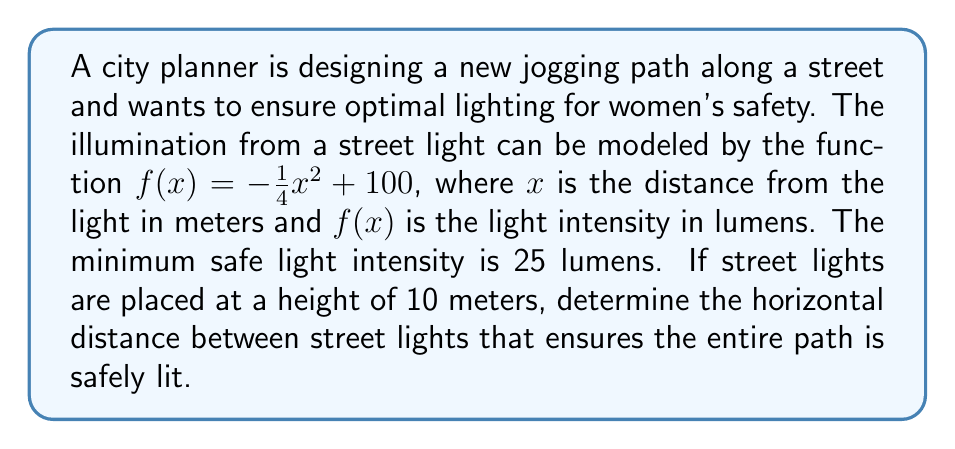Show me your answer to this math problem. 1) First, we need to account for the height of the street lights. This creates a vertical shift of 10 meters upward. The new function is:

   $g(x) = f(x-10) = -\frac{1}{4}(x-10)^2 + 100$

2) We need to find where this function equals 25 lumens:

   $25 = -\frac{1}{4}(x-10)^2 + 100$

3) Subtract 100 from both sides:

   $-75 = -\frac{1}{4}(x-10)^2$

4) Multiply both sides by -4:

   $300 = (x-10)^2$

5) Take the square root of both sides:

   $\sqrt{300} = |x-10|$

6) Solve for x:

   $x = 10 \pm \sqrt{300} \approx 10 \pm 17.32$

7) This means the safe lighting extends 17.32 meters on each side of the light post.

8) For continuous safe lighting, the distance between posts should be double this:

   $2 * 17.32 = 34.64$ meters
Answer: 34.64 meters 